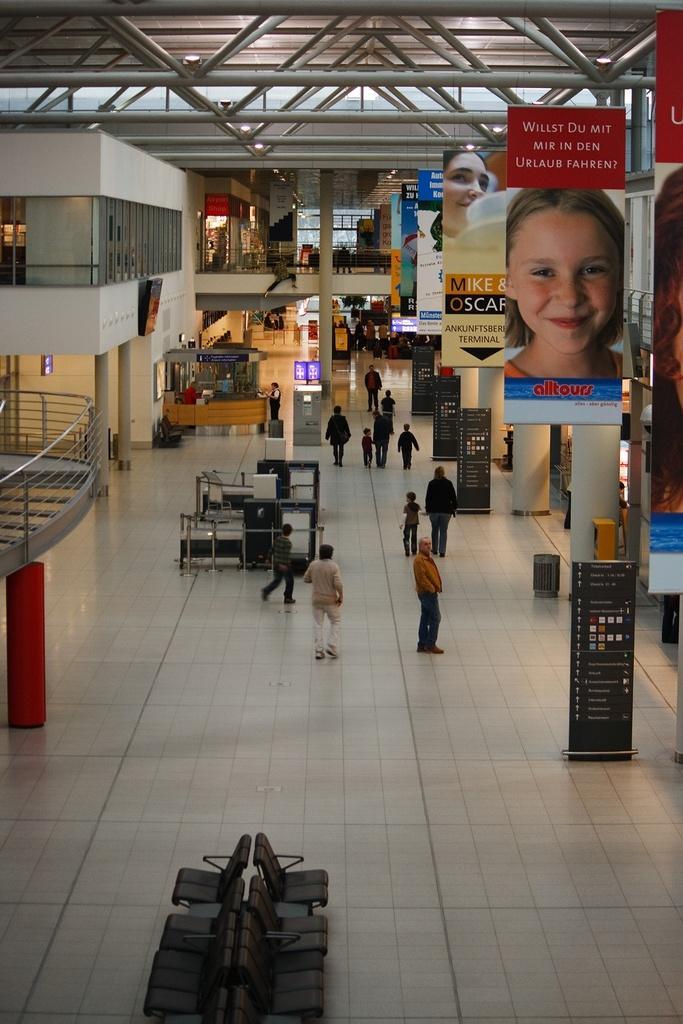Can you describe this image briefly? This image is taken indoors. At the bottom of the image there is a floor. There are many empty chairs on the floor. At the top of the image there is a roof and there are many iron bars. On the right side of the image there are many boards with text on them. There are a few images on boards and there are a few pillars and there is a dustbin on the floor. On the left side of the image there is a railing. There are a few pillars and walls. In the middle of the image there are a few walls with windows. There are a few pillars, railings and stores. A few people walking on the floor and a few are standing on the floor. 